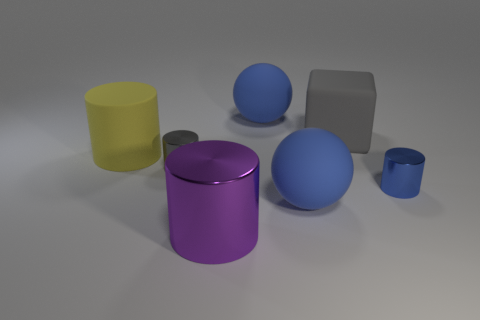Subtract all blue cylinders. How many cylinders are left? 3 Add 2 large shiny things. How many objects exist? 9 Subtract all blue cylinders. How many cylinders are left? 3 Subtract all cubes. How many objects are left? 6 Subtract 0 red blocks. How many objects are left? 7 Subtract all blue cylinders. Subtract all blue spheres. How many cylinders are left? 3 Subtract all blue rubber things. Subtract all blue objects. How many objects are left? 2 Add 4 big purple metal cylinders. How many big purple metal cylinders are left? 5 Add 3 small yellow metal things. How many small yellow metal things exist? 3 